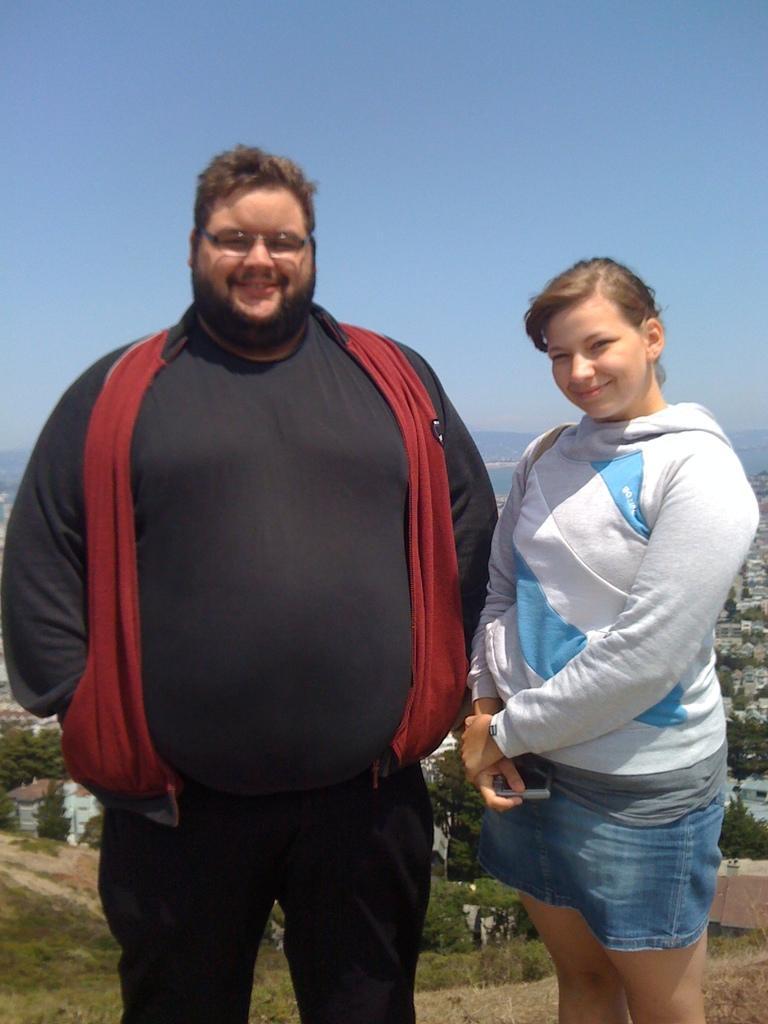Please provide a concise description of this image. In this image we can see a man and a woman standing on the ground, a woman is holding an object looks like a camera and in the background there are few buildings, trees and the sky. 